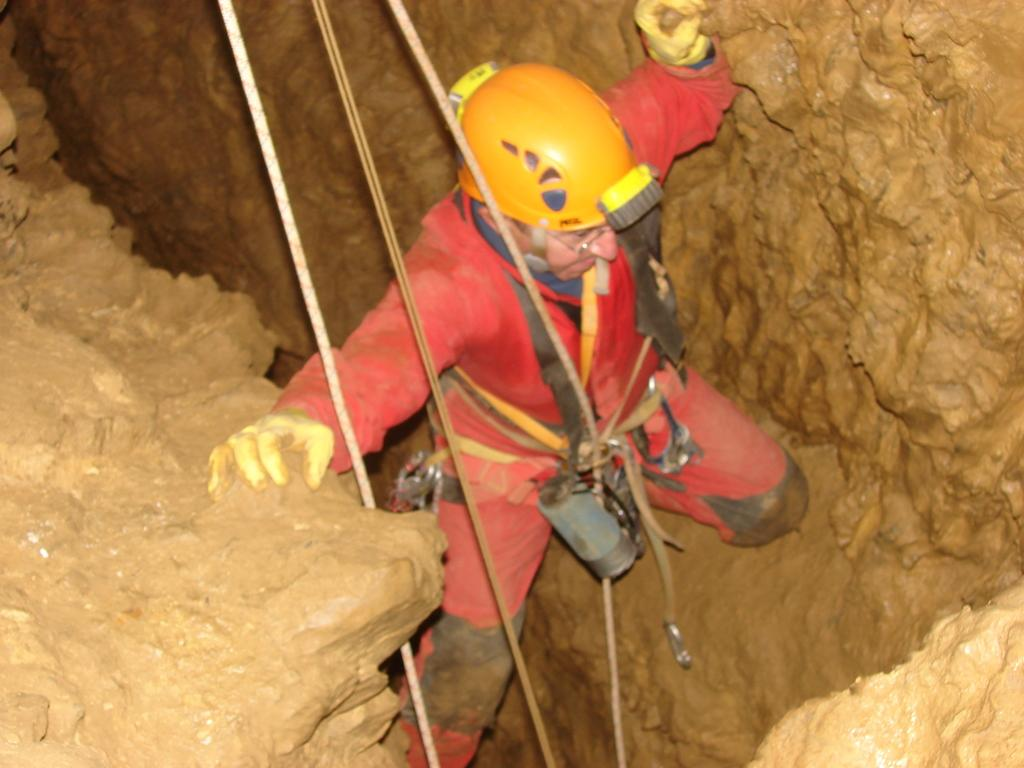What is the main subject of the image? There is a man standing in the middle of the image. What objects can be seen in the image besides the man? There are ropes in the image. What can be seen in the background of the image? There is a hole visible in the background of the image. What type of behavior does the ladybug exhibit in the image? There is no ladybug present in the image, so it is not possible to determine its behavior. 